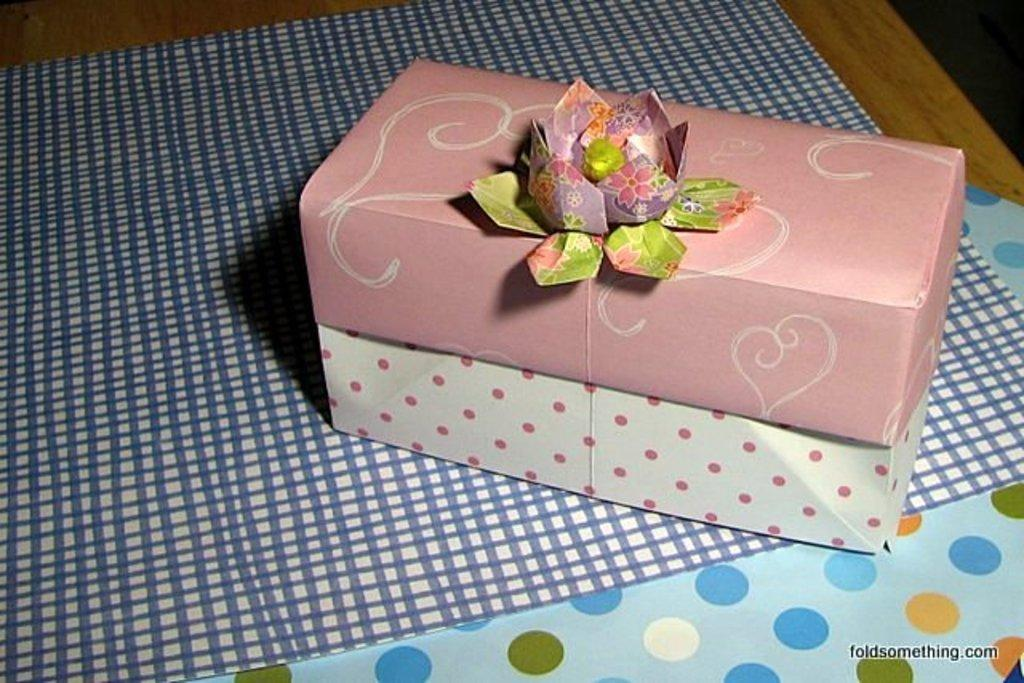What object is placed on the table in the image? There is a gift box on the table. What type of material is covering the table? There is cloth on the table. What else is present on the table besides the gift box and cloth? There is paper on the table. Can you read any text in the image? Yes, there is text at the bottom of the image. How much does the gift box weigh in the image? The weight of the gift box cannot be determined from the image alone. --- 